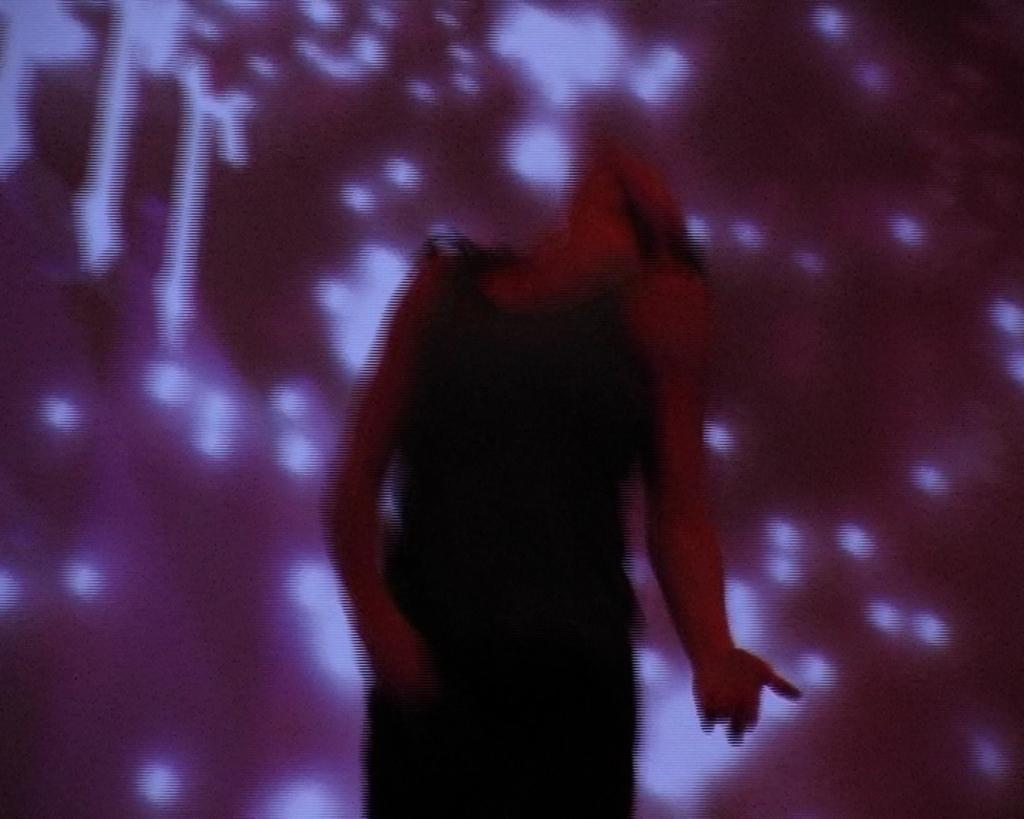What is the main subject of the image? There is a person in the image. Can you describe the background of the image? The background of the image is blurry. What can be seen in the background of the image? There are lights visible in the background of the image. What type of furniture is being used by the person's son in the image? There is no mention of a son or any furniture in the image. 